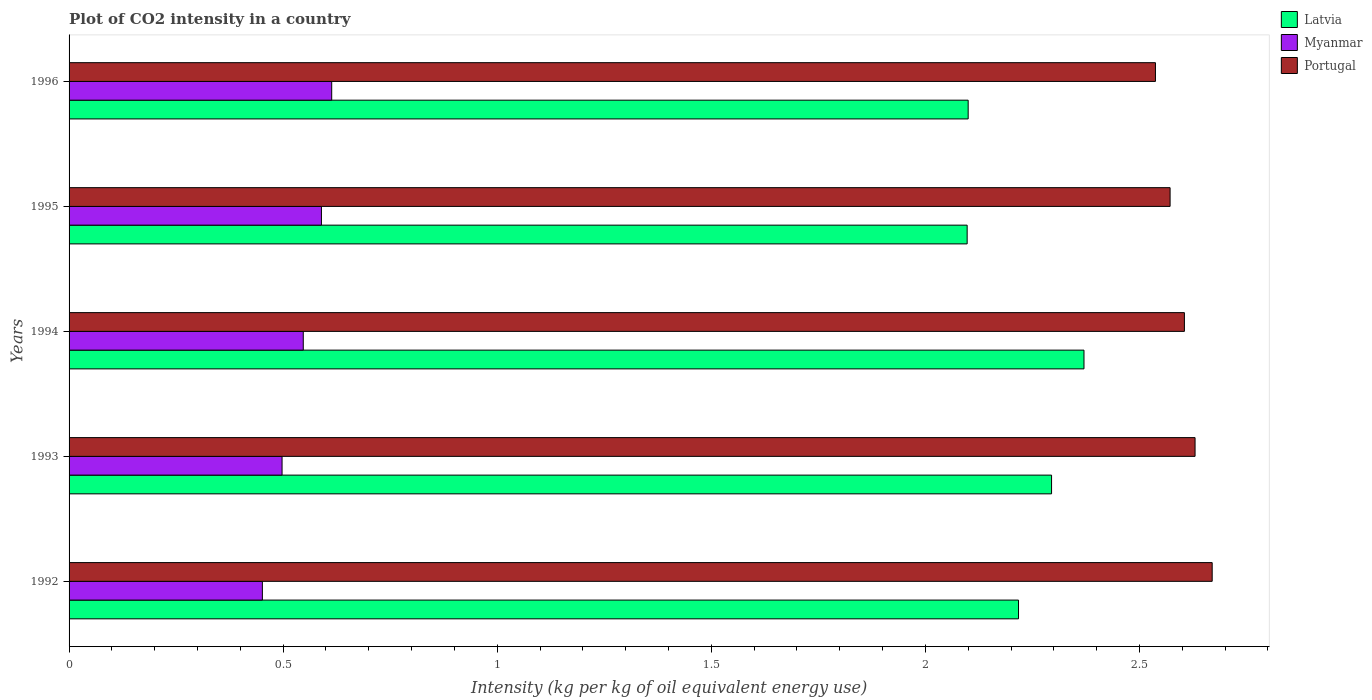How many groups of bars are there?
Offer a very short reply. 5. Are the number of bars on each tick of the Y-axis equal?
Provide a succinct answer. Yes. How many bars are there on the 4th tick from the bottom?
Your response must be concise. 3. What is the label of the 5th group of bars from the top?
Provide a short and direct response. 1992. In how many cases, is the number of bars for a given year not equal to the number of legend labels?
Offer a terse response. 0. What is the CO2 intensity in in Portugal in 1992?
Your answer should be compact. 2.67. Across all years, what is the maximum CO2 intensity in in Latvia?
Give a very brief answer. 2.37. Across all years, what is the minimum CO2 intensity in in Myanmar?
Make the answer very short. 0.45. What is the total CO2 intensity in in Portugal in the graph?
Offer a terse response. 13.01. What is the difference between the CO2 intensity in in Portugal in 1992 and that in 1994?
Your answer should be very brief. 0.06. What is the difference between the CO2 intensity in in Latvia in 1992 and the CO2 intensity in in Myanmar in 1996?
Give a very brief answer. 1.6. What is the average CO2 intensity in in Myanmar per year?
Provide a succinct answer. 0.54. In the year 1995, what is the difference between the CO2 intensity in in Myanmar and CO2 intensity in in Latvia?
Make the answer very short. -1.51. In how many years, is the CO2 intensity in in Portugal greater than 2.5 kg?
Your response must be concise. 5. What is the ratio of the CO2 intensity in in Portugal in 1995 to that in 1996?
Provide a succinct answer. 1.01. What is the difference between the highest and the second highest CO2 intensity in in Portugal?
Give a very brief answer. 0.04. What is the difference between the highest and the lowest CO2 intensity in in Portugal?
Provide a short and direct response. 0.13. In how many years, is the CO2 intensity in in Portugal greater than the average CO2 intensity in in Portugal taken over all years?
Offer a very short reply. 3. Is the sum of the CO2 intensity in in Latvia in 1992 and 1995 greater than the maximum CO2 intensity in in Portugal across all years?
Make the answer very short. Yes. What does the 3rd bar from the top in 1992 represents?
Your answer should be compact. Latvia. What does the 1st bar from the bottom in 1995 represents?
Provide a short and direct response. Latvia. Is it the case that in every year, the sum of the CO2 intensity in in Latvia and CO2 intensity in in Myanmar is greater than the CO2 intensity in in Portugal?
Ensure brevity in your answer.  No. Are all the bars in the graph horizontal?
Provide a short and direct response. Yes. Does the graph contain grids?
Your answer should be very brief. No. How many legend labels are there?
Your answer should be compact. 3. How are the legend labels stacked?
Keep it short and to the point. Vertical. What is the title of the graph?
Keep it short and to the point. Plot of CO2 intensity in a country. Does "Malta" appear as one of the legend labels in the graph?
Provide a succinct answer. No. What is the label or title of the X-axis?
Give a very brief answer. Intensity (kg per kg of oil equivalent energy use). What is the label or title of the Y-axis?
Ensure brevity in your answer.  Years. What is the Intensity (kg per kg of oil equivalent energy use) of Latvia in 1992?
Provide a short and direct response. 2.22. What is the Intensity (kg per kg of oil equivalent energy use) of Myanmar in 1992?
Provide a short and direct response. 0.45. What is the Intensity (kg per kg of oil equivalent energy use) in Portugal in 1992?
Give a very brief answer. 2.67. What is the Intensity (kg per kg of oil equivalent energy use) in Latvia in 1993?
Your response must be concise. 2.29. What is the Intensity (kg per kg of oil equivalent energy use) of Myanmar in 1993?
Offer a very short reply. 0.5. What is the Intensity (kg per kg of oil equivalent energy use) in Portugal in 1993?
Your answer should be compact. 2.63. What is the Intensity (kg per kg of oil equivalent energy use) in Latvia in 1994?
Provide a succinct answer. 2.37. What is the Intensity (kg per kg of oil equivalent energy use) in Myanmar in 1994?
Ensure brevity in your answer.  0.55. What is the Intensity (kg per kg of oil equivalent energy use) of Portugal in 1994?
Provide a succinct answer. 2.6. What is the Intensity (kg per kg of oil equivalent energy use) of Latvia in 1995?
Offer a very short reply. 2.1. What is the Intensity (kg per kg of oil equivalent energy use) in Myanmar in 1995?
Keep it short and to the point. 0.59. What is the Intensity (kg per kg of oil equivalent energy use) of Portugal in 1995?
Your response must be concise. 2.57. What is the Intensity (kg per kg of oil equivalent energy use) of Latvia in 1996?
Provide a succinct answer. 2.1. What is the Intensity (kg per kg of oil equivalent energy use) of Myanmar in 1996?
Offer a very short reply. 0.61. What is the Intensity (kg per kg of oil equivalent energy use) in Portugal in 1996?
Provide a short and direct response. 2.54. Across all years, what is the maximum Intensity (kg per kg of oil equivalent energy use) of Latvia?
Give a very brief answer. 2.37. Across all years, what is the maximum Intensity (kg per kg of oil equivalent energy use) in Myanmar?
Your answer should be compact. 0.61. Across all years, what is the maximum Intensity (kg per kg of oil equivalent energy use) in Portugal?
Offer a very short reply. 2.67. Across all years, what is the minimum Intensity (kg per kg of oil equivalent energy use) in Latvia?
Ensure brevity in your answer.  2.1. Across all years, what is the minimum Intensity (kg per kg of oil equivalent energy use) in Myanmar?
Provide a short and direct response. 0.45. Across all years, what is the minimum Intensity (kg per kg of oil equivalent energy use) of Portugal?
Your answer should be compact. 2.54. What is the total Intensity (kg per kg of oil equivalent energy use) of Latvia in the graph?
Provide a succinct answer. 11.08. What is the total Intensity (kg per kg of oil equivalent energy use) of Myanmar in the graph?
Keep it short and to the point. 2.7. What is the total Intensity (kg per kg of oil equivalent energy use) of Portugal in the graph?
Provide a short and direct response. 13.01. What is the difference between the Intensity (kg per kg of oil equivalent energy use) in Latvia in 1992 and that in 1993?
Your response must be concise. -0.08. What is the difference between the Intensity (kg per kg of oil equivalent energy use) of Myanmar in 1992 and that in 1993?
Keep it short and to the point. -0.05. What is the difference between the Intensity (kg per kg of oil equivalent energy use) of Portugal in 1992 and that in 1993?
Your answer should be very brief. 0.04. What is the difference between the Intensity (kg per kg of oil equivalent energy use) of Latvia in 1992 and that in 1994?
Keep it short and to the point. -0.15. What is the difference between the Intensity (kg per kg of oil equivalent energy use) of Myanmar in 1992 and that in 1994?
Give a very brief answer. -0.1. What is the difference between the Intensity (kg per kg of oil equivalent energy use) of Portugal in 1992 and that in 1994?
Make the answer very short. 0.06. What is the difference between the Intensity (kg per kg of oil equivalent energy use) of Latvia in 1992 and that in 1995?
Provide a short and direct response. 0.12. What is the difference between the Intensity (kg per kg of oil equivalent energy use) in Myanmar in 1992 and that in 1995?
Make the answer very short. -0.14. What is the difference between the Intensity (kg per kg of oil equivalent energy use) of Portugal in 1992 and that in 1995?
Your answer should be compact. 0.1. What is the difference between the Intensity (kg per kg of oil equivalent energy use) in Latvia in 1992 and that in 1996?
Offer a terse response. 0.12. What is the difference between the Intensity (kg per kg of oil equivalent energy use) of Myanmar in 1992 and that in 1996?
Make the answer very short. -0.16. What is the difference between the Intensity (kg per kg of oil equivalent energy use) in Portugal in 1992 and that in 1996?
Your answer should be compact. 0.13. What is the difference between the Intensity (kg per kg of oil equivalent energy use) of Latvia in 1993 and that in 1994?
Offer a terse response. -0.08. What is the difference between the Intensity (kg per kg of oil equivalent energy use) of Myanmar in 1993 and that in 1994?
Give a very brief answer. -0.05. What is the difference between the Intensity (kg per kg of oil equivalent energy use) in Portugal in 1993 and that in 1994?
Give a very brief answer. 0.02. What is the difference between the Intensity (kg per kg of oil equivalent energy use) in Latvia in 1993 and that in 1995?
Provide a short and direct response. 0.2. What is the difference between the Intensity (kg per kg of oil equivalent energy use) in Myanmar in 1993 and that in 1995?
Offer a terse response. -0.09. What is the difference between the Intensity (kg per kg of oil equivalent energy use) in Portugal in 1993 and that in 1995?
Provide a succinct answer. 0.06. What is the difference between the Intensity (kg per kg of oil equivalent energy use) in Latvia in 1993 and that in 1996?
Offer a terse response. 0.19. What is the difference between the Intensity (kg per kg of oil equivalent energy use) of Myanmar in 1993 and that in 1996?
Offer a terse response. -0.12. What is the difference between the Intensity (kg per kg of oil equivalent energy use) of Portugal in 1993 and that in 1996?
Keep it short and to the point. 0.09. What is the difference between the Intensity (kg per kg of oil equivalent energy use) in Latvia in 1994 and that in 1995?
Keep it short and to the point. 0.27. What is the difference between the Intensity (kg per kg of oil equivalent energy use) of Myanmar in 1994 and that in 1995?
Give a very brief answer. -0.04. What is the difference between the Intensity (kg per kg of oil equivalent energy use) in Portugal in 1994 and that in 1995?
Your answer should be very brief. 0.03. What is the difference between the Intensity (kg per kg of oil equivalent energy use) in Latvia in 1994 and that in 1996?
Give a very brief answer. 0.27. What is the difference between the Intensity (kg per kg of oil equivalent energy use) of Myanmar in 1994 and that in 1996?
Keep it short and to the point. -0.07. What is the difference between the Intensity (kg per kg of oil equivalent energy use) in Portugal in 1994 and that in 1996?
Your answer should be compact. 0.07. What is the difference between the Intensity (kg per kg of oil equivalent energy use) in Latvia in 1995 and that in 1996?
Your response must be concise. -0. What is the difference between the Intensity (kg per kg of oil equivalent energy use) of Myanmar in 1995 and that in 1996?
Provide a succinct answer. -0.02. What is the difference between the Intensity (kg per kg of oil equivalent energy use) of Portugal in 1995 and that in 1996?
Offer a very short reply. 0.03. What is the difference between the Intensity (kg per kg of oil equivalent energy use) of Latvia in 1992 and the Intensity (kg per kg of oil equivalent energy use) of Myanmar in 1993?
Your response must be concise. 1.72. What is the difference between the Intensity (kg per kg of oil equivalent energy use) in Latvia in 1992 and the Intensity (kg per kg of oil equivalent energy use) in Portugal in 1993?
Your response must be concise. -0.41. What is the difference between the Intensity (kg per kg of oil equivalent energy use) in Myanmar in 1992 and the Intensity (kg per kg of oil equivalent energy use) in Portugal in 1993?
Give a very brief answer. -2.18. What is the difference between the Intensity (kg per kg of oil equivalent energy use) in Latvia in 1992 and the Intensity (kg per kg of oil equivalent energy use) in Myanmar in 1994?
Your response must be concise. 1.67. What is the difference between the Intensity (kg per kg of oil equivalent energy use) of Latvia in 1992 and the Intensity (kg per kg of oil equivalent energy use) of Portugal in 1994?
Your answer should be very brief. -0.39. What is the difference between the Intensity (kg per kg of oil equivalent energy use) in Myanmar in 1992 and the Intensity (kg per kg of oil equivalent energy use) in Portugal in 1994?
Offer a very short reply. -2.15. What is the difference between the Intensity (kg per kg of oil equivalent energy use) of Latvia in 1992 and the Intensity (kg per kg of oil equivalent energy use) of Myanmar in 1995?
Offer a very short reply. 1.63. What is the difference between the Intensity (kg per kg of oil equivalent energy use) in Latvia in 1992 and the Intensity (kg per kg of oil equivalent energy use) in Portugal in 1995?
Your response must be concise. -0.35. What is the difference between the Intensity (kg per kg of oil equivalent energy use) in Myanmar in 1992 and the Intensity (kg per kg of oil equivalent energy use) in Portugal in 1995?
Your answer should be very brief. -2.12. What is the difference between the Intensity (kg per kg of oil equivalent energy use) of Latvia in 1992 and the Intensity (kg per kg of oil equivalent energy use) of Myanmar in 1996?
Your answer should be compact. 1.6. What is the difference between the Intensity (kg per kg of oil equivalent energy use) of Latvia in 1992 and the Intensity (kg per kg of oil equivalent energy use) of Portugal in 1996?
Keep it short and to the point. -0.32. What is the difference between the Intensity (kg per kg of oil equivalent energy use) in Myanmar in 1992 and the Intensity (kg per kg of oil equivalent energy use) in Portugal in 1996?
Keep it short and to the point. -2.09. What is the difference between the Intensity (kg per kg of oil equivalent energy use) of Latvia in 1993 and the Intensity (kg per kg of oil equivalent energy use) of Myanmar in 1994?
Give a very brief answer. 1.75. What is the difference between the Intensity (kg per kg of oil equivalent energy use) of Latvia in 1993 and the Intensity (kg per kg of oil equivalent energy use) of Portugal in 1994?
Your answer should be very brief. -0.31. What is the difference between the Intensity (kg per kg of oil equivalent energy use) of Myanmar in 1993 and the Intensity (kg per kg of oil equivalent energy use) of Portugal in 1994?
Your answer should be compact. -2.11. What is the difference between the Intensity (kg per kg of oil equivalent energy use) in Latvia in 1993 and the Intensity (kg per kg of oil equivalent energy use) in Myanmar in 1995?
Make the answer very short. 1.71. What is the difference between the Intensity (kg per kg of oil equivalent energy use) of Latvia in 1993 and the Intensity (kg per kg of oil equivalent energy use) of Portugal in 1995?
Offer a very short reply. -0.28. What is the difference between the Intensity (kg per kg of oil equivalent energy use) of Myanmar in 1993 and the Intensity (kg per kg of oil equivalent energy use) of Portugal in 1995?
Your answer should be very brief. -2.07. What is the difference between the Intensity (kg per kg of oil equivalent energy use) in Latvia in 1993 and the Intensity (kg per kg of oil equivalent energy use) in Myanmar in 1996?
Offer a very short reply. 1.68. What is the difference between the Intensity (kg per kg of oil equivalent energy use) in Latvia in 1993 and the Intensity (kg per kg of oil equivalent energy use) in Portugal in 1996?
Give a very brief answer. -0.24. What is the difference between the Intensity (kg per kg of oil equivalent energy use) of Myanmar in 1993 and the Intensity (kg per kg of oil equivalent energy use) of Portugal in 1996?
Ensure brevity in your answer.  -2.04. What is the difference between the Intensity (kg per kg of oil equivalent energy use) of Latvia in 1994 and the Intensity (kg per kg of oil equivalent energy use) of Myanmar in 1995?
Give a very brief answer. 1.78. What is the difference between the Intensity (kg per kg of oil equivalent energy use) in Latvia in 1994 and the Intensity (kg per kg of oil equivalent energy use) in Portugal in 1995?
Give a very brief answer. -0.2. What is the difference between the Intensity (kg per kg of oil equivalent energy use) in Myanmar in 1994 and the Intensity (kg per kg of oil equivalent energy use) in Portugal in 1995?
Offer a very short reply. -2.02. What is the difference between the Intensity (kg per kg of oil equivalent energy use) in Latvia in 1994 and the Intensity (kg per kg of oil equivalent energy use) in Myanmar in 1996?
Your response must be concise. 1.76. What is the difference between the Intensity (kg per kg of oil equivalent energy use) in Latvia in 1994 and the Intensity (kg per kg of oil equivalent energy use) in Portugal in 1996?
Offer a very short reply. -0.17. What is the difference between the Intensity (kg per kg of oil equivalent energy use) in Myanmar in 1994 and the Intensity (kg per kg of oil equivalent energy use) in Portugal in 1996?
Provide a short and direct response. -1.99. What is the difference between the Intensity (kg per kg of oil equivalent energy use) in Latvia in 1995 and the Intensity (kg per kg of oil equivalent energy use) in Myanmar in 1996?
Provide a succinct answer. 1.48. What is the difference between the Intensity (kg per kg of oil equivalent energy use) in Latvia in 1995 and the Intensity (kg per kg of oil equivalent energy use) in Portugal in 1996?
Offer a very short reply. -0.44. What is the difference between the Intensity (kg per kg of oil equivalent energy use) of Myanmar in 1995 and the Intensity (kg per kg of oil equivalent energy use) of Portugal in 1996?
Keep it short and to the point. -1.95. What is the average Intensity (kg per kg of oil equivalent energy use) of Latvia per year?
Keep it short and to the point. 2.22. What is the average Intensity (kg per kg of oil equivalent energy use) of Myanmar per year?
Ensure brevity in your answer.  0.54. What is the average Intensity (kg per kg of oil equivalent energy use) in Portugal per year?
Provide a succinct answer. 2.6. In the year 1992, what is the difference between the Intensity (kg per kg of oil equivalent energy use) in Latvia and Intensity (kg per kg of oil equivalent energy use) in Myanmar?
Your response must be concise. 1.77. In the year 1992, what is the difference between the Intensity (kg per kg of oil equivalent energy use) of Latvia and Intensity (kg per kg of oil equivalent energy use) of Portugal?
Provide a succinct answer. -0.45. In the year 1992, what is the difference between the Intensity (kg per kg of oil equivalent energy use) in Myanmar and Intensity (kg per kg of oil equivalent energy use) in Portugal?
Offer a very short reply. -2.22. In the year 1993, what is the difference between the Intensity (kg per kg of oil equivalent energy use) in Latvia and Intensity (kg per kg of oil equivalent energy use) in Myanmar?
Provide a succinct answer. 1.8. In the year 1993, what is the difference between the Intensity (kg per kg of oil equivalent energy use) in Latvia and Intensity (kg per kg of oil equivalent energy use) in Portugal?
Your answer should be compact. -0.34. In the year 1993, what is the difference between the Intensity (kg per kg of oil equivalent energy use) in Myanmar and Intensity (kg per kg of oil equivalent energy use) in Portugal?
Provide a short and direct response. -2.13. In the year 1994, what is the difference between the Intensity (kg per kg of oil equivalent energy use) of Latvia and Intensity (kg per kg of oil equivalent energy use) of Myanmar?
Your response must be concise. 1.82. In the year 1994, what is the difference between the Intensity (kg per kg of oil equivalent energy use) in Latvia and Intensity (kg per kg of oil equivalent energy use) in Portugal?
Make the answer very short. -0.23. In the year 1994, what is the difference between the Intensity (kg per kg of oil equivalent energy use) of Myanmar and Intensity (kg per kg of oil equivalent energy use) of Portugal?
Make the answer very short. -2.06. In the year 1995, what is the difference between the Intensity (kg per kg of oil equivalent energy use) in Latvia and Intensity (kg per kg of oil equivalent energy use) in Myanmar?
Give a very brief answer. 1.51. In the year 1995, what is the difference between the Intensity (kg per kg of oil equivalent energy use) in Latvia and Intensity (kg per kg of oil equivalent energy use) in Portugal?
Ensure brevity in your answer.  -0.47. In the year 1995, what is the difference between the Intensity (kg per kg of oil equivalent energy use) of Myanmar and Intensity (kg per kg of oil equivalent energy use) of Portugal?
Give a very brief answer. -1.98. In the year 1996, what is the difference between the Intensity (kg per kg of oil equivalent energy use) of Latvia and Intensity (kg per kg of oil equivalent energy use) of Myanmar?
Your answer should be compact. 1.49. In the year 1996, what is the difference between the Intensity (kg per kg of oil equivalent energy use) of Latvia and Intensity (kg per kg of oil equivalent energy use) of Portugal?
Provide a succinct answer. -0.44. In the year 1996, what is the difference between the Intensity (kg per kg of oil equivalent energy use) of Myanmar and Intensity (kg per kg of oil equivalent energy use) of Portugal?
Offer a terse response. -1.92. What is the ratio of the Intensity (kg per kg of oil equivalent energy use) of Latvia in 1992 to that in 1993?
Provide a short and direct response. 0.97. What is the ratio of the Intensity (kg per kg of oil equivalent energy use) of Myanmar in 1992 to that in 1993?
Offer a terse response. 0.91. What is the ratio of the Intensity (kg per kg of oil equivalent energy use) of Portugal in 1992 to that in 1993?
Provide a short and direct response. 1.02. What is the ratio of the Intensity (kg per kg of oil equivalent energy use) of Latvia in 1992 to that in 1994?
Your answer should be very brief. 0.94. What is the ratio of the Intensity (kg per kg of oil equivalent energy use) of Myanmar in 1992 to that in 1994?
Ensure brevity in your answer.  0.83. What is the ratio of the Intensity (kg per kg of oil equivalent energy use) in Portugal in 1992 to that in 1994?
Provide a succinct answer. 1.02. What is the ratio of the Intensity (kg per kg of oil equivalent energy use) of Latvia in 1992 to that in 1995?
Keep it short and to the point. 1.06. What is the ratio of the Intensity (kg per kg of oil equivalent energy use) in Myanmar in 1992 to that in 1995?
Provide a short and direct response. 0.77. What is the ratio of the Intensity (kg per kg of oil equivalent energy use) in Portugal in 1992 to that in 1995?
Provide a succinct answer. 1.04. What is the ratio of the Intensity (kg per kg of oil equivalent energy use) in Latvia in 1992 to that in 1996?
Offer a very short reply. 1.06. What is the ratio of the Intensity (kg per kg of oil equivalent energy use) of Myanmar in 1992 to that in 1996?
Your response must be concise. 0.74. What is the ratio of the Intensity (kg per kg of oil equivalent energy use) of Portugal in 1992 to that in 1996?
Your response must be concise. 1.05. What is the ratio of the Intensity (kg per kg of oil equivalent energy use) in Latvia in 1993 to that in 1994?
Your response must be concise. 0.97. What is the ratio of the Intensity (kg per kg of oil equivalent energy use) of Myanmar in 1993 to that in 1994?
Keep it short and to the point. 0.91. What is the ratio of the Intensity (kg per kg of oil equivalent energy use) in Portugal in 1993 to that in 1994?
Provide a short and direct response. 1.01. What is the ratio of the Intensity (kg per kg of oil equivalent energy use) of Latvia in 1993 to that in 1995?
Provide a succinct answer. 1.09. What is the ratio of the Intensity (kg per kg of oil equivalent energy use) of Myanmar in 1993 to that in 1995?
Offer a terse response. 0.84. What is the ratio of the Intensity (kg per kg of oil equivalent energy use) of Portugal in 1993 to that in 1995?
Offer a very short reply. 1.02. What is the ratio of the Intensity (kg per kg of oil equivalent energy use) of Latvia in 1993 to that in 1996?
Provide a succinct answer. 1.09. What is the ratio of the Intensity (kg per kg of oil equivalent energy use) of Myanmar in 1993 to that in 1996?
Make the answer very short. 0.81. What is the ratio of the Intensity (kg per kg of oil equivalent energy use) in Portugal in 1993 to that in 1996?
Your answer should be compact. 1.04. What is the ratio of the Intensity (kg per kg of oil equivalent energy use) in Latvia in 1994 to that in 1995?
Give a very brief answer. 1.13. What is the ratio of the Intensity (kg per kg of oil equivalent energy use) in Myanmar in 1994 to that in 1995?
Give a very brief answer. 0.93. What is the ratio of the Intensity (kg per kg of oil equivalent energy use) of Portugal in 1994 to that in 1995?
Give a very brief answer. 1.01. What is the ratio of the Intensity (kg per kg of oil equivalent energy use) of Latvia in 1994 to that in 1996?
Keep it short and to the point. 1.13. What is the ratio of the Intensity (kg per kg of oil equivalent energy use) of Myanmar in 1994 to that in 1996?
Provide a short and direct response. 0.89. What is the ratio of the Intensity (kg per kg of oil equivalent energy use) of Portugal in 1994 to that in 1996?
Provide a short and direct response. 1.03. What is the ratio of the Intensity (kg per kg of oil equivalent energy use) of Latvia in 1995 to that in 1996?
Your answer should be compact. 1. What is the ratio of the Intensity (kg per kg of oil equivalent energy use) of Myanmar in 1995 to that in 1996?
Provide a short and direct response. 0.96. What is the ratio of the Intensity (kg per kg of oil equivalent energy use) of Portugal in 1995 to that in 1996?
Offer a terse response. 1.01. What is the difference between the highest and the second highest Intensity (kg per kg of oil equivalent energy use) of Latvia?
Offer a very short reply. 0.08. What is the difference between the highest and the second highest Intensity (kg per kg of oil equivalent energy use) in Myanmar?
Give a very brief answer. 0.02. What is the difference between the highest and the lowest Intensity (kg per kg of oil equivalent energy use) in Latvia?
Give a very brief answer. 0.27. What is the difference between the highest and the lowest Intensity (kg per kg of oil equivalent energy use) of Myanmar?
Your response must be concise. 0.16. What is the difference between the highest and the lowest Intensity (kg per kg of oil equivalent energy use) of Portugal?
Offer a terse response. 0.13. 